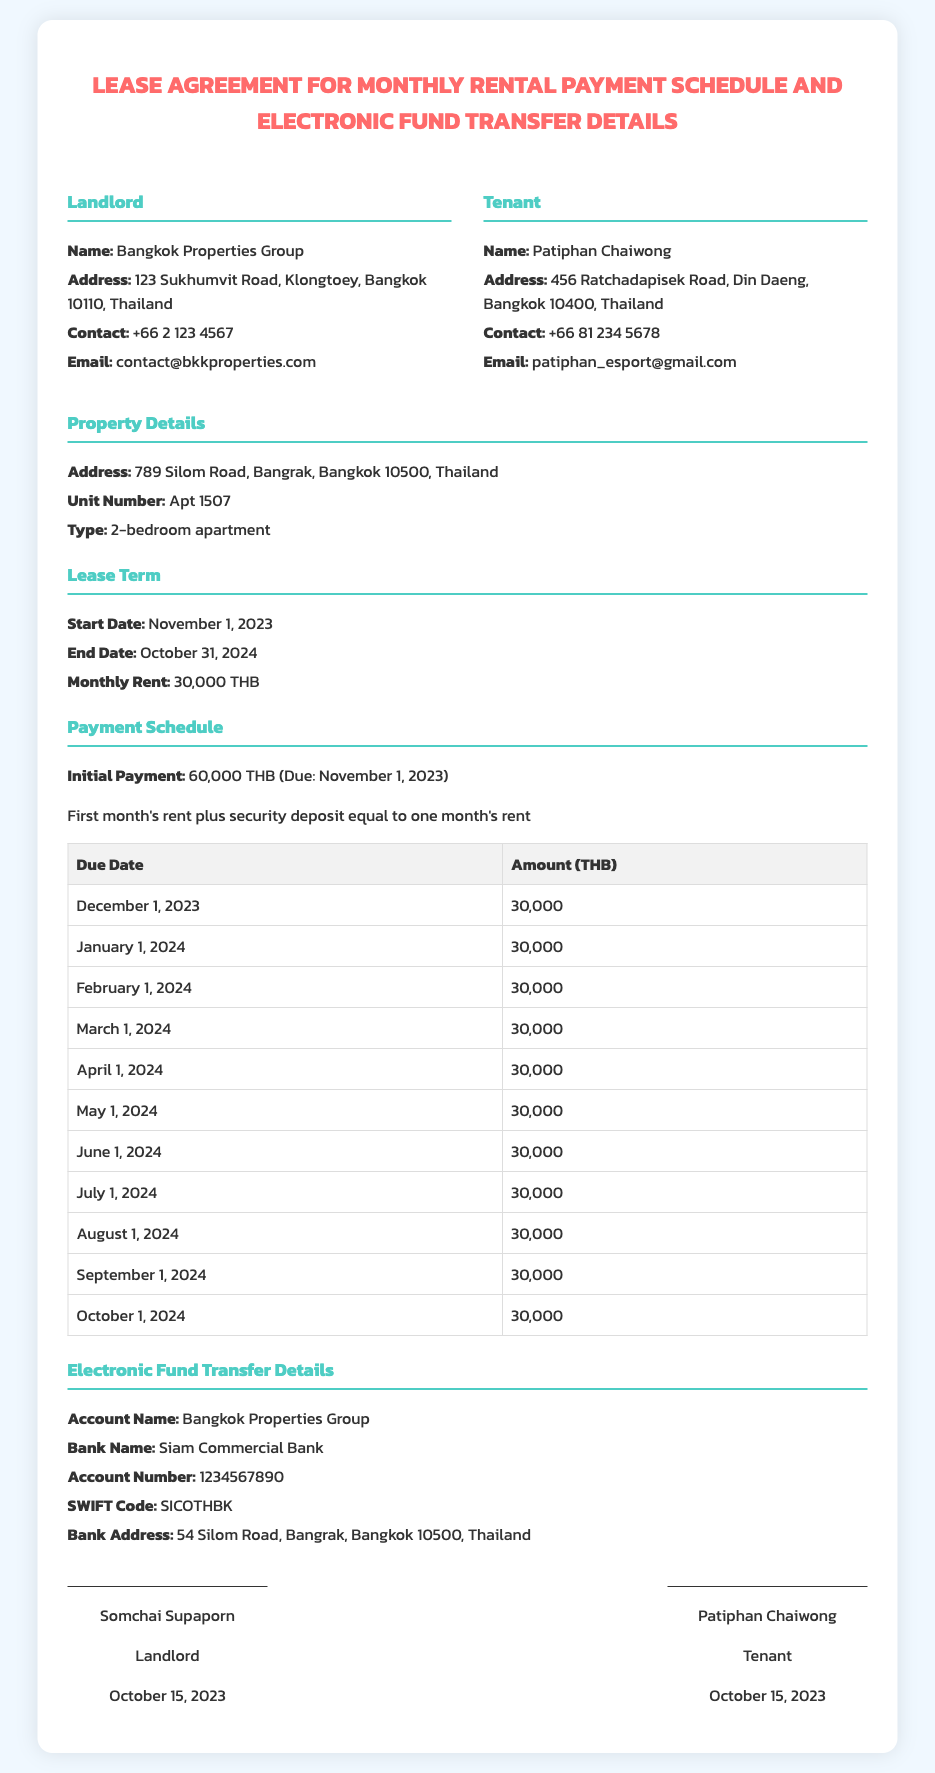What is the name of the landlord? The landlord's name is listed in the document under the party details section.
Answer: Bangkok Properties Group What is the monthly rent amount? The monthly rent amount is explicitly mentioned in the Lease Term section of the document.
Answer: 30,000 THB When is the initial payment due? The due date for the initial payment is specified in the Payment Schedule section of the document.
Answer: November 1, 2023 How many times is the monthly rent due during the lease term? The document outlines payment due dates through the entire lease term, indicating the number of monthly payments.
Answer: 12 What is the account number for the electronic fund transfer? The account number is found in the Electronic Fund Transfer Details section of the document.
Answer: 1234567890 What is the property address? The property address is mentioned in the Property Details section of the document.
Answer: 789 Silom Road, Bangrak, Bangkok 10500, Thailand Who is the tenant? The tenant's name is located in the party details section.
Answer: Patiphan Chaiwong What is the SWIFT code for the bank? The SWIFT code can be found in the Electronic Fund Transfer Details section.
Answer: SICOTHBK What type of apartment is being leased? The type of apartment is specified in the Property Details section of the document.
Answer: 2-bedroom apartment 